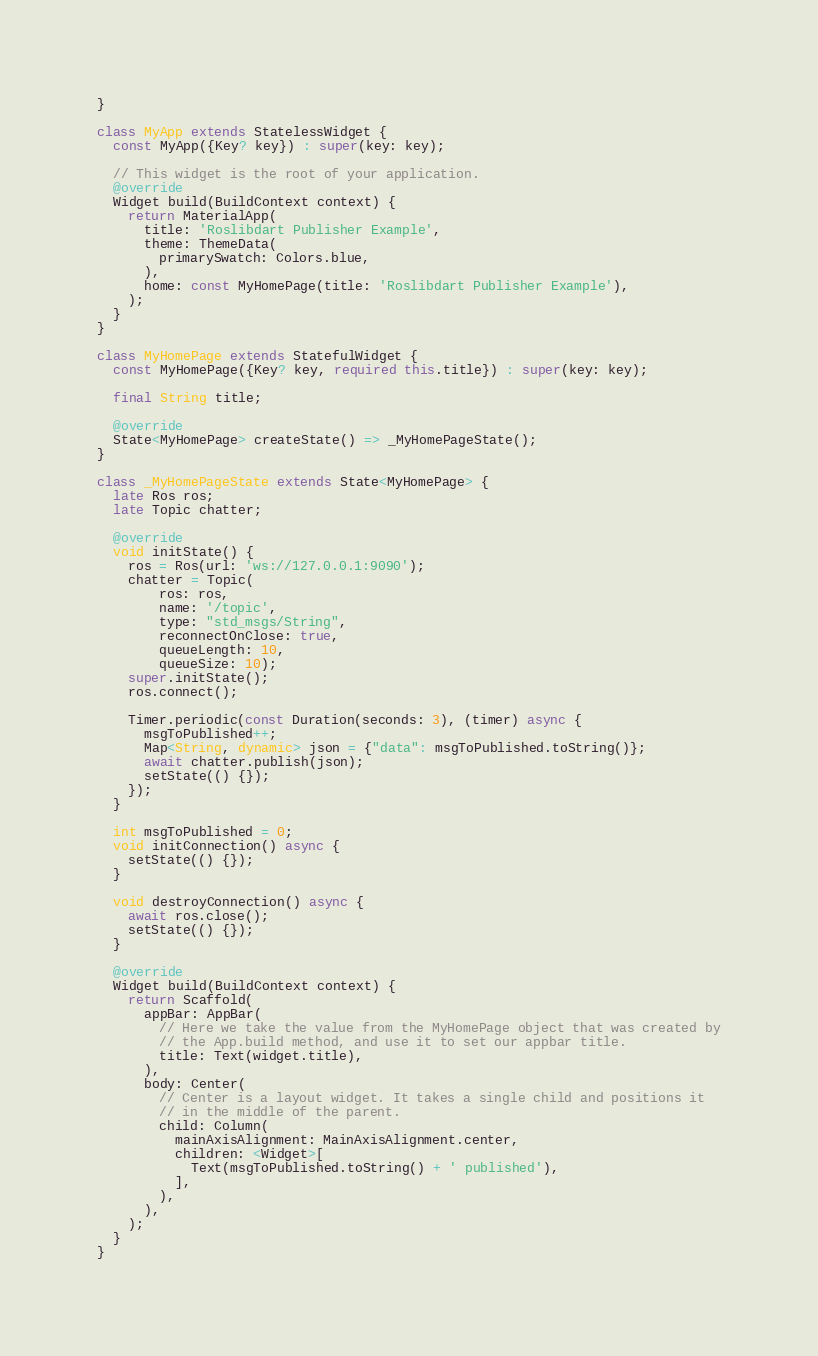Convert code to text. <code><loc_0><loc_0><loc_500><loc_500><_Dart_>}

class MyApp extends StatelessWidget {
  const MyApp({Key? key}) : super(key: key);

  // This widget is the root of your application.
  @override
  Widget build(BuildContext context) {
    return MaterialApp(
      title: 'Roslibdart Publisher Example',
      theme: ThemeData(
        primarySwatch: Colors.blue,
      ),
      home: const MyHomePage(title: 'Roslibdart Publisher Example'),
    );
  }
}

class MyHomePage extends StatefulWidget {
  const MyHomePage({Key? key, required this.title}) : super(key: key);

  final String title;

  @override
  State<MyHomePage> createState() => _MyHomePageState();
}

class _MyHomePageState extends State<MyHomePage> {
  late Ros ros;
  late Topic chatter;

  @override
  void initState() {
    ros = Ros(url: 'ws://127.0.0.1:9090');
    chatter = Topic(
        ros: ros,
        name: '/topic',
        type: "std_msgs/String",
        reconnectOnClose: true,
        queueLength: 10,
        queueSize: 10);
    super.initState();
    ros.connect();

    Timer.periodic(const Duration(seconds: 3), (timer) async {
      msgToPublished++;
      Map<String, dynamic> json = {"data": msgToPublished.toString()};
      await chatter.publish(json);
      setState(() {});
    });
  }

  int msgToPublished = 0;
  void initConnection() async {
    setState(() {});
  }

  void destroyConnection() async {
    await ros.close();
    setState(() {});
  }

  @override
  Widget build(BuildContext context) {
    return Scaffold(
      appBar: AppBar(
        // Here we take the value from the MyHomePage object that was created by
        // the App.build method, and use it to set our appbar title.
        title: Text(widget.title),
      ),
      body: Center(
        // Center is a layout widget. It takes a single child and positions it
        // in the middle of the parent.
        child: Column(
          mainAxisAlignment: MainAxisAlignment.center,
          children: <Widget>[
            Text(msgToPublished.toString() + ' published'),
          ],
        ),
      ),
    );
  }
}
</code> 